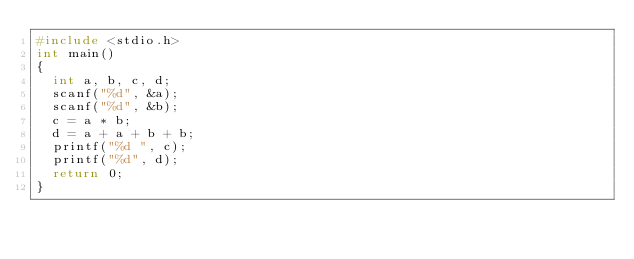<code> <loc_0><loc_0><loc_500><loc_500><_C_>#include <stdio.h>
int main()
{
	int a, b, c, d;
	scanf("%d", &a);
	scanf("%d", &b);
	c = a * b;
	d = a + a + b + b;
	printf("%d ", c);
	printf("%d", d);
	return 0;
}
</code> 